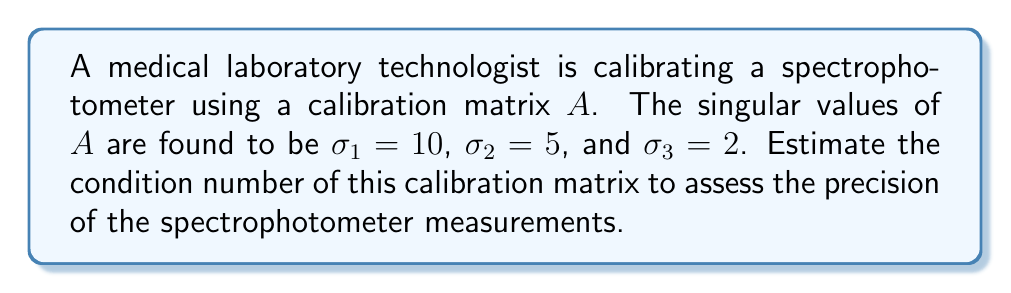Give your solution to this math problem. To estimate the condition number of the calibration matrix, we'll follow these steps:

1) The condition number of a matrix is defined as the ratio of the largest singular value to the smallest singular value:

   $$ \kappa(A) = \frac{\sigma_{\text{max}}}{\sigma_{\text{min}}} $$

2) From the given information:
   - Largest singular value: $\sigma_{\text{max}} = \sigma_1 = 10$
   - Smallest singular value: $\sigma_{\text{min}} = \sigma_3 = 2$

3) Substituting these values into the condition number formula:

   $$ \kappa(A) = \frac{10}{2} = 5 $$

4) Interpretation: A condition number of 5 indicates that the calibration matrix is relatively well-conditioned. This suggests that small errors in the input data (e.g., spectrophotometer readings) will result in proportionally small errors in the output (calibrated values). The spectrophotometer measurements can be considered reasonably precise.

Note: In practice, condition numbers much larger than this (e.g., 1000 or more) would indicate potential precision issues with the equipment or calibration process.
Answer: $\kappa(A) = 5$ 